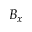Convert formula to latex. <formula><loc_0><loc_0><loc_500><loc_500>B _ { x }</formula> 